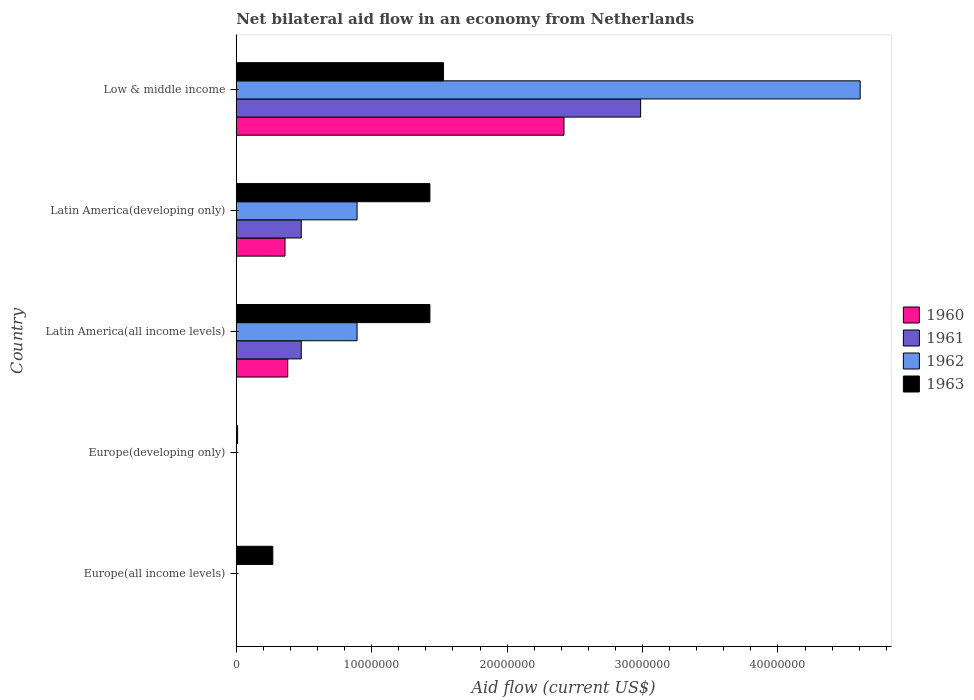Are the number of bars per tick equal to the number of legend labels?
Your answer should be very brief. No. Are the number of bars on each tick of the Y-axis equal?
Provide a succinct answer. No. How many bars are there on the 1st tick from the bottom?
Offer a terse response. 1. What is the label of the 2nd group of bars from the top?
Offer a very short reply. Latin America(developing only). In how many cases, is the number of bars for a given country not equal to the number of legend labels?
Give a very brief answer. 2. Across all countries, what is the maximum net bilateral aid flow in 1963?
Your response must be concise. 1.53e+07. What is the total net bilateral aid flow in 1962 in the graph?
Make the answer very short. 6.39e+07. What is the difference between the net bilateral aid flow in 1963 in Latin America(all income levels) and that in Low & middle income?
Your answer should be very brief. -1.00e+06. What is the difference between the net bilateral aid flow in 1960 in Latin America(all income levels) and the net bilateral aid flow in 1963 in Latin America(developing only)?
Provide a succinct answer. -1.05e+07. What is the average net bilateral aid flow in 1962 per country?
Offer a terse response. 1.28e+07. What is the difference between the net bilateral aid flow in 1961 and net bilateral aid flow in 1963 in Latin America(developing only)?
Provide a succinct answer. -9.50e+06. What is the ratio of the net bilateral aid flow in 1962 in Latin America(developing only) to that in Low & middle income?
Make the answer very short. 0.19. Is the net bilateral aid flow in 1960 in Latin America(all income levels) less than that in Low & middle income?
Offer a terse response. Yes. What is the difference between the highest and the second highest net bilateral aid flow in 1960?
Your response must be concise. 2.04e+07. What is the difference between the highest and the lowest net bilateral aid flow in 1962?
Provide a short and direct response. 4.61e+07. Is the sum of the net bilateral aid flow in 1963 in Europe(all income levels) and Latin America(developing only) greater than the maximum net bilateral aid flow in 1961 across all countries?
Offer a very short reply. No. Is it the case that in every country, the sum of the net bilateral aid flow in 1963 and net bilateral aid flow in 1960 is greater than the sum of net bilateral aid flow in 1961 and net bilateral aid flow in 1962?
Provide a short and direct response. No. Is it the case that in every country, the sum of the net bilateral aid flow in 1960 and net bilateral aid flow in 1963 is greater than the net bilateral aid flow in 1961?
Give a very brief answer. Yes. How many bars are there?
Your response must be concise. 14. Are all the bars in the graph horizontal?
Offer a terse response. Yes. How many countries are there in the graph?
Provide a succinct answer. 5. Does the graph contain any zero values?
Make the answer very short. Yes. Does the graph contain grids?
Your answer should be very brief. No. Where does the legend appear in the graph?
Provide a short and direct response. Center right. How many legend labels are there?
Provide a succinct answer. 4. What is the title of the graph?
Your answer should be very brief. Net bilateral aid flow in an economy from Netherlands. Does "1963" appear as one of the legend labels in the graph?
Provide a succinct answer. Yes. What is the label or title of the X-axis?
Make the answer very short. Aid flow (current US$). What is the Aid flow (current US$) in 1960 in Europe(all income levels)?
Offer a very short reply. 0. What is the Aid flow (current US$) in 1961 in Europe(all income levels)?
Keep it short and to the point. 0. What is the Aid flow (current US$) in 1963 in Europe(all income levels)?
Your answer should be very brief. 2.70e+06. What is the Aid flow (current US$) in 1960 in Europe(developing only)?
Your response must be concise. 0. What is the Aid flow (current US$) in 1961 in Europe(developing only)?
Your answer should be very brief. 0. What is the Aid flow (current US$) in 1960 in Latin America(all income levels)?
Keep it short and to the point. 3.80e+06. What is the Aid flow (current US$) in 1961 in Latin America(all income levels)?
Offer a very short reply. 4.80e+06. What is the Aid flow (current US$) of 1962 in Latin America(all income levels)?
Offer a terse response. 8.92e+06. What is the Aid flow (current US$) of 1963 in Latin America(all income levels)?
Keep it short and to the point. 1.43e+07. What is the Aid flow (current US$) in 1960 in Latin America(developing only)?
Your answer should be compact. 3.60e+06. What is the Aid flow (current US$) in 1961 in Latin America(developing only)?
Offer a very short reply. 4.80e+06. What is the Aid flow (current US$) in 1962 in Latin America(developing only)?
Your answer should be compact. 8.92e+06. What is the Aid flow (current US$) of 1963 in Latin America(developing only)?
Keep it short and to the point. 1.43e+07. What is the Aid flow (current US$) in 1960 in Low & middle income?
Provide a short and direct response. 2.42e+07. What is the Aid flow (current US$) of 1961 in Low & middle income?
Provide a short and direct response. 2.99e+07. What is the Aid flow (current US$) in 1962 in Low & middle income?
Give a very brief answer. 4.61e+07. What is the Aid flow (current US$) of 1963 in Low & middle income?
Ensure brevity in your answer.  1.53e+07. Across all countries, what is the maximum Aid flow (current US$) in 1960?
Provide a short and direct response. 2.42e+07. Across all countries, what is the maximum Aid flow (current US$) of 1961?
Provide a succinct answer. 2.99e+07. Across all countries, what is the maximum Aid flow (current US$) of 1962?
Give a very brief answer. 4.61e+07. Across all countries, what is the maximum Aid flow (current US$) of 1963?
Keep it short and to the point. 1.53e+07. Across all countries, what is the minimum Aid flow (current US$) in 1960?
Offer a very short reply. 0. Across all countries, what is the minimum Aid flow (current US$) of 1961?
Provide a short and direct response. 0. What is the total Aid flow (current US$) in 1960 in the graph?
Offer a terse response. 3.16e+07. What is the total Aid flow (current US$) in 1961 in the graph?
Offer a terse response. 3.95e+07. What is the total Aid flow (current US$) in 1962 in the graph?
Provide a short and direct response. 6.39e+07. What is the total Aid flow (current US$) of 1963 in the graph?
Provide a short and direct response. 4.67e+07. What is the difference between the Aid flow (current US$) of 1963 in Europe(all income levels) and that in Europe(developing only)?
Offer a terse response. 2.60e+06. What is the difference between the Aid flow (current US$) of 1963 in Europe(all income levels) and that in Latin America(all income levels)?
Ensure brevity in your answer.  -1.16e+07. What is the difference between the Aid flow (current US$) in 1963 in Europe(all income levels) and that in Latin America(developing only)?
Ensure brevity in your answer.  -1.16e+07. What is the difference between the Aid flow (current US$) of 1963 in Europe(all income levels) and that in Low & middle income?
Offer a very short reply. -1.26e+07. What is the difference between the Aid flow (current US$) of 1963 in Europe(developing only) and that in Latin America(all income levels)?
Offer a terse response. -1.42e+07. What is the difference between the Aid flow (current US$) of 1963 in Europe(developing only) and that in Latin America(developing only)?
Ensure brevity in your answer.  -1.42e+07. What is the difference between the Aid flow (current US$) of 1963 in Europe(developing only) and that in Low & middle income?
Your answer should be compact. -1.52e+07. What is the difference between the Aid flow (current US$) in 1960 in Latin America(all income levels) and that in Latin America(developing only)?
Offer a terse response. 2.00e+05. What is the difference between the Aid flow (current US$) of 1962 in Latin America(all income levels) and that in Latin America(developing only)?
Provide a short and direct response. 0. What is the difference between the Aid flow (current US$) of 1960 in Latin America(all income levels) and that in Low & middle income?
Offer a terse response. -2.04e+07. What is the difference between the Aid flow (current US$) in 1961 in Latin America(all income levels) and that in Low & middle income?
Keep it short and to the point. -2.51e+07. What is the difference between the Aid flow (current US$) of 1962 in Latin America(all income levels) and that in Low & middle income?
Provide a short and direct response. -3.72e+07. What is the difference between the Aid flow (current US$) of 1963 in Latin America(all income levels) and that in Low & middle income?
Your response must be concise. -1.00e+06. What is the difference between the Aid flow (current US$) in 1960 in Latin America(developing only) and that in Low & middle income?
Ensure brevity in your answer.  -2.06e+07. What is the difference between the Aid flow (current US$) in 1961 in Latin America(developing only) and that in Low & middle income?
Offer a very short reply. -2.51e+07. What is the difference between the Aid flow (current US$) of 1962 in Latin America(developing only) and that in Low & middle income?
Ensure brevity in your answer.  -3.72e+07. What is the difference between the Aid flow (current US$) of 1960 in Latin America(all income levels) and the Aid flow (current US$) of 1962 in Latin America(developing only)?
Give a very brief answer. -5.12e+06. What is the difference between the Aid flow (current US$) of 1960 in Latin America(all income levels) and the Aid flow (current US$) of 1963 in Latin America(developing only)?
Ensure brevity in your answer.  -1.05e+07. What is the difference between the Aid flow (current US$) of 1961 in Latin America(all income levels) and the Aid flow (current US$) of 1962 in Latin America(developing only)?
Offer a very short reply. -4.12e+06. What is the difference between the Aid flow (current US$) in 1961 in Latin America(all income levels) and the Aid flow (current US$) in 1963 in Latin America(developing only)?
Give a very brief answer. -9.50e+06. What is the difference between the Aid flow (current US$) of 1962 in Latin America(all income levels) and the Aid flow (current US$) of 1963 in Latin America(developing only)?
Your answer should be very brief. -5.38e+06. What is the difference between the Aid flow (current US$) in 1960 in Latin America(all income levels) and the Aid flow (current US$) in 1961 in Low & middle income?
Ensure brevity in your answer.  -2.61e+07. What is the difference between the Aid flow (current US$) in 1960 in Latin America(all income levels) and the Aid flow (current US$) in 1962 in Low & middle income?
Your answer should be compact. -4.23e+07. What is the difference between the Aid flow (current US$) of 1960 in Latin America(all income levels) and the Aid flow (current US$) of 1963 in Low & middle income?
Offer a very short reply. -1.15e+07. What is the difference between the Aid flow (current US$) of 1961 in Latin America(all income levels) and the Aid flow (current US$) of 1962 in Low & middle income?
Ensure brevity in your answer.  -4.13e+07. What is the difference between the Aid flow (current US$) in 1961 in Latin America(all income levels) and the Aid flow (current US$) in 1963 in Low & middle income?
Make the answer very short. -1.05e+07. What is the difference between the Aid flow (current US$) of 1962 in Latin America(all income levels) and the Aid flow (current US$) of 1963 in Low & middle income?
Give a very brief answer. -6.38e+06. What is the difference between the Aid flow (current US$) in 1960 in Latin America(developing only) and the Aid flow (current US$) in 1961 in Low & middle income?
Offer a very short reply. -2.63e+07. What is the difference between the Aid flow (current US$) in 1960 in Latin America(developing only) and the Aid flow (current US$) in 1962 in Low & middle income?
Your answer should be compact. -4.25e+07. What is the difference between the Aid flow (current US$) in 1960 in Latin America(developing only) and the Aid flow (current US$) in 1963 in Low & middle income?
Make the answer very short. -1.17e+07. What is the difference between the Aid flow (current US$) in 1961 in Latin America(developing only) and the Aid flow (current US$) in 1962 in Low & middle income?
Give a very brief answer. -4.13e+07. What is the difference between the Aid flow (current US$) in 1961 in Latin America(developing only) and the Aid flow (current US$) in 1963 in Low & middle income?
Give a very brief answer. -1.05e+07. What is the difference between the Aid flow (current US$) of 1962 in Latin America(developing only) and the Aid flow (current US$) of 1963 in Low & middle income?
Keep it short and to the point. -6.38e+06. What is the average Aid flow (current US$) of 1960 per country?
Ensure brevity in your answer.  6.32e+06. What is the average Aid flow (current US$) of 1961 per country?
Offer a terse response. 7.89e+06. What is the average Aid flow (current US$) of 1962 per country?
Provide a succinct answer. 1.28e+07. What is the average Aid flow (current US$) in 1963 per country?
Provide a short and direct response. 9.34e+06. What is the difference between the Aid flow (current US$) of 1960 and Aid flow (current US$) of 1961 in Latin America(all income levels)?
Your response must be concise. -1.00e+06. What is the difference between the Aid flow (current US$) in 1960 and Aid flow (current US$) in 1962 in Latin America(all income levels)?
Make the answer very short. -5.12e+06. What is the difference between the Aid flow (current US$) in 1960 and Aid flow (current US$) in 1963 in Latin America(all income levels)?
Offer a very short reply. -1.05e+07. What is the difference between the Aid flow (current US$) in 1961 and Aid flow (current US$) in 1962 in Latin America(all income levels)?
Keep it short and to the point. -4.12e+06. What is the difference between the Aid flow (current US$) in 1961 and Aid flow (current US$) in 1963 in Latin America(all income levels)?
Ensure brevity in your answer.  -9.50e+06. What is the difference between the Aid flow (current US$) in 1962 and Aid flow (current US$) in 1963 in Latin America(all income levels)?
Ensure brevity in your answer.  -5.38e+06. What is the difference between the Aid flow (current US$) of 1960 and Aid flow (current US$) of 1961 in Latin America(developing only)?
Give a very brief answer. -1.20e+06. What is the difference between the Aid flow (current US$) in 1960 and Aid flow (current US$) in 1962 in Latin America(developing only)?
Ensure brevity in your answer.  -5.32e+06. What is the difference between the Aid flow (current US$) in 1960 and Aid flow (current US$) in 1963 in Latin America(developing only)?
Ensure brevity in your answer.  -1.07e+07. What is the difference between the Aid flow (current US$) in 1961 and Aid flow (current US$) in 1962 in Latin America(developing only)?
Your response must be concise. -4.12e+06. What is the difference between the Aid flow (current US$) in 1961 and Aid flow (current US$) in 1963 in Latin America(developing only)?
Ensure brevity in your answer.  -9.50e+06. What is the difference between the Aid flow (current US$) in 1962 and Aid flow (current US$) in 1963 in Latin America(developing only)?
Offer a terse response. -5.38e+06. What is the difference between the Aid flow (current US$) of 1960 and Aid flow (current US$) of 1961 in Low & middle income?
Your answer should be compact. -5.66e+06. What is the difference between the Aid flow (current US$) of 1960 and Aid flow (current US$) of 1962 in Low & middle income?
Make the answer very short. -2.19e+07. What is the difference between the Aid flow (current US$) in 1960 and Aid flow (current US$) in 1963 in Low & middle income?
Offer a terse response. 8.90e+06. What is the difference between the Aid flow (current US$) in 1961 and Aid flow (current US$) in 1962 in Low & middle income?
Offer a terse response. -1.62e+07. What is the difference between the Aid flow (current US$) of 1961 and Aid flow (current US$) of 1963 in Low & middle income?
Offer a terse response. 1.46e+07. What is the difference between the Aid flow (current US$) of 1962 and Aid flow (current US$) of 1963 in Low & middle income?
Provide a succinct answer. 3.08e+07. What is the ratio of the Aid flow (current US$) of 1963 in Europe(all income levels) to that in Europe(developing only)?
Make the answer very short. 27. What is the ratio of the Aid flow (current US$) of 1963 in Europe(all income levels) to that in Latin America(all income levels)?
Provide a succinct answer. 0.19. What is the ratio of the Aid flow (current US$) of 1963 in Europe(all income levels) to that in Latin America(developing only)?
Provide a short and direct response. 0.19. What is the ratio of the Aid flow (current US$) of 1963 in Europe(all income levels) to that in Low & middle income?
Provide a short and direct response. 0.18. What is the ratio of the Aid flow (current US$) in 1963 in Europe(developing only) to that in Latin America(all income levels)?
Give a very brief answer. 0.01. What is the ratio of the Aid flow (current US$) in 1963 in Europe(developing only) to that in Latin America(developing only)?
Ensure brevity in your answer.  0.01. What is the ratio of the Aid flow (current US$) in 1963 in Europe(developing only) to that in Low & middle income?
Give a very brief answer. 0.01. What is the ratio of the Aid flow (current US$) of 1960 in Latin America(all income levels) to that in Latin America(developing only)?
Provide a succinct answer. 1.06. What is the ratio of the Aid flow (current US$) in 1961 in Latin America(all income levels) to that in Latin America(developing only)?
Give a very brief answer. 1. What is the ratio of the Aid flow (current US$) in 1962 in Latin America(all income levels) to that in Latin America(developing only)?
Keep it short and to the point. 1. What is the ratio of the Aid flow (current US$) in 1963 in Latin America(all income levels) to that in Latin America(developing only)?
Offer a very short reply. 1. What is the ratio of the Aid flow (current US$) in 1960 in Latin America(all income levels) to that in Low & middle income?
Make the answer very short. 0.16. What is the ratio of the Aid flow (current US$) in 1961 in Latin America(all income levels) to that in Low & middle income?
Provide a short and direct response. 0.16. What is the ratio of the Aid flow (current US$) in 1962 in Latin America(all income levels) to that in Low & middle income?
Your answer should be compact. 0.19. What is the ratio of the Aid flow (current US$) of 1963 in Latin America(all income levels) to that in Low & middle income?
Make the answer very short. 0.93. What is the ratio of the Aid flow (current US$) of 1960 in Latin America(developing only) to that in Low & middle income?
Keep it short and to the point. 0.15. What is the ratio of the Aid flow (current US$) of 1961 in Latin America(developing only) to that in Low & middle income?
Provide a succinct answer. 0.16. What is the ratio of the Aid flow (current US$) in 1962 in Latin America(developing only) to that in Low & middle income?
Make the answer very short. 0.19. What is the ratio of the Aid flow (current US$) in 1963 in Latin America(developing only) to that in Low & middle income?
Provide a succinct answer. 0.93. What is the difference between the highest and the second highest Aid flow (current US$) of 1960?
Offer a very short reply. 2.04e+07. What is the difference between the highest and the second highest Aid flow (current US$) in 1961?
Give a very brief answer. 2.51e+07. What is the difference between the highest and the second highest Aid flow (current US$) of 1962?
Make the answer very short. 3.72e+07. What is the difference between the highest and the lowest Aid flow (current US$) of 1960?
Your answer should be compact. 2.42e+07. What is the difference between the highest and the lowest Aid flow (current US$) of 1961?
Offer a terse response. 2.99e+07. What is the difference between the highest and the lowest Aid flow (current US$) in 1962?
Your response must be concise. 4.61e+07. What is the difference between the highest and the lowest Aid flow (current US$) in 1963?
Provide a short and direct response. 1.52e+07. 